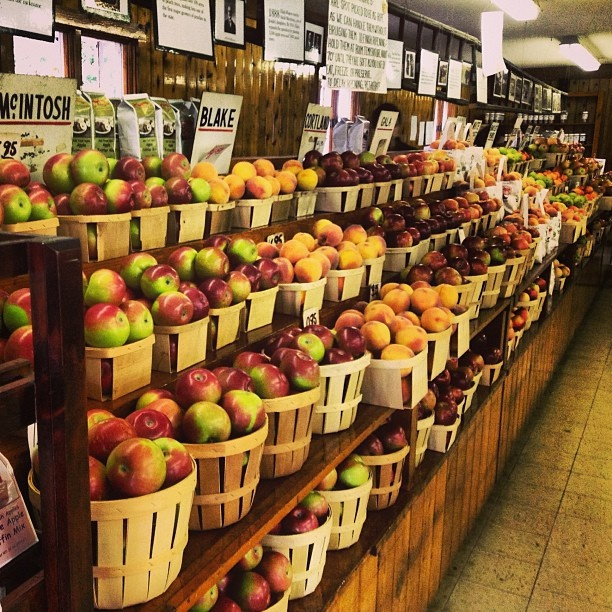Describe the objects in this image and their specific colors. I can see apple in darkgray, black, maroon, tan, and brown tones, apple in darkgray, maroon, brown, and black tones, apple in darkgray, maroon, brown, black, and khaki tones, apple in darkgray, orange, gold, and maroon tones, and apple in darkgray, maroon, orange, brown, and red tones in this image. 